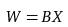Convert formula to latex. <formula><loc_0><loc_0><loc_500><loc_500>W = B X</formula> 